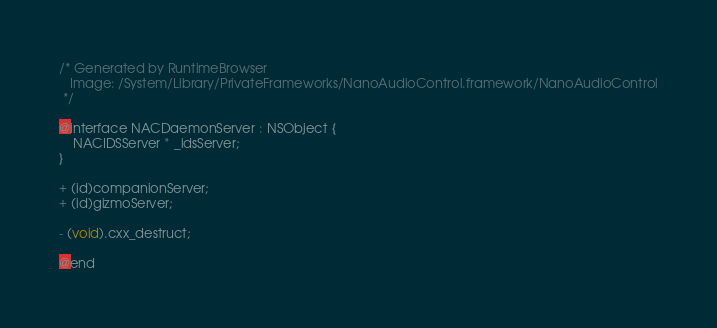<code> <loc_0><loc_0><loc_500><loc_500><_C_>/* Generated by RuntimeBrowser
   Image: /System/Library/PrivateFrameworks/NanoAudioControl.framework/NanoAudioControl
 */

@interface NACDaemonServer : NSObject {
    NACIDSServer * _idsServer;
}

+ (id)companionServer;
+ (id)gizmoServer;

- (void).cxx_destruct;

@end
</code> 